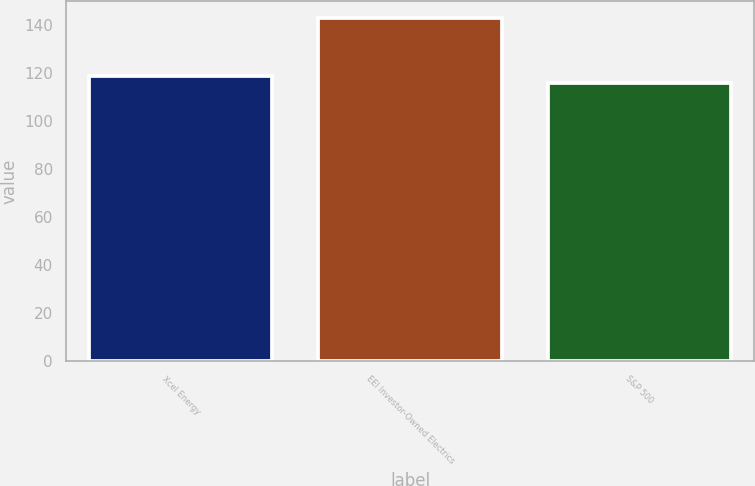Convert chart to OTSL. <chart><loc_0><loc_0><loc_500><loc_500><bar_chart><fcel>Xcel Energy<fcel>EEI Investor-Owned Electrics<fcel>S&P 500<nl><fcel>119<fcel>143<fcel>116<nl></chart> 